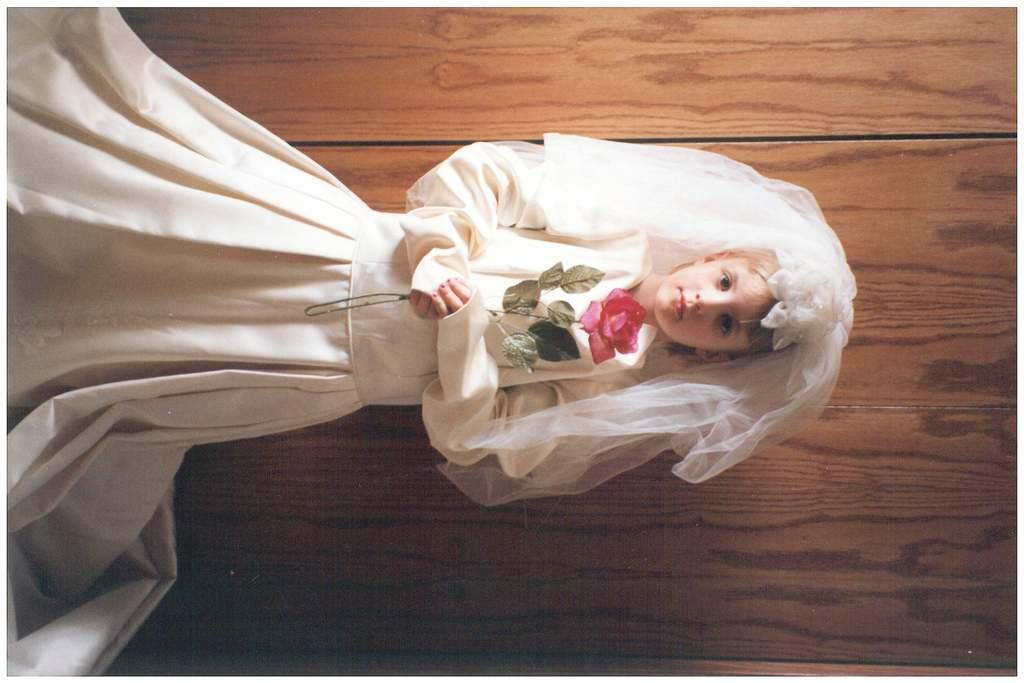Who is the main subject in the picture? There is a girl in the picture. What is the girl wearing? The girl is wearing a wedding dress. What is the girl holding in her hands? The girl is holding a flower in her hands. What type of wall can be seen in the picture? There is a wooden wall in the picture. Are there any sheep visible in the picture? No, there are no sheep present in the image. What type of trousers is the girl wearing with her wedding dress? The girl is not wearing trousers; she is wearing a wedding dress. 